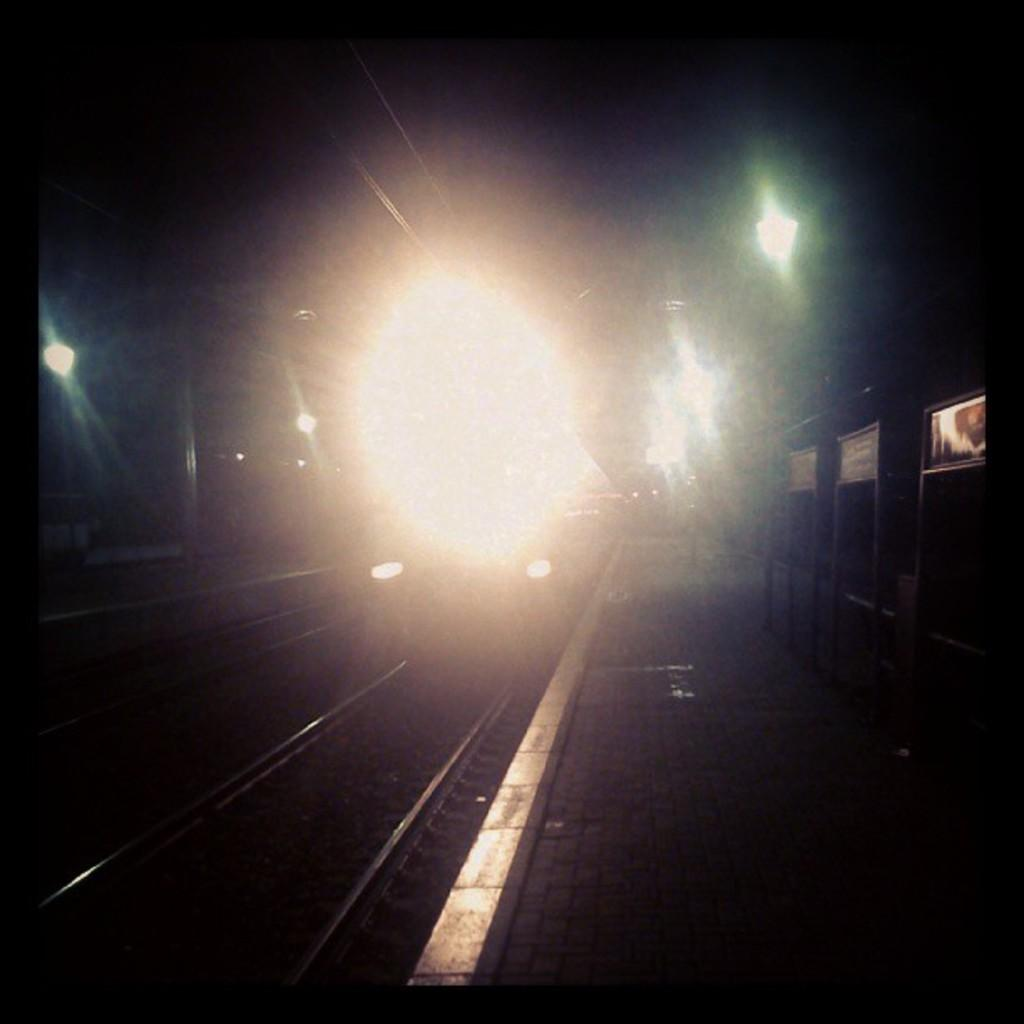What is the main subject of the image? The main subject of the image is a train. Where is the train located in the image? The train is on a track in the image. What can be seen on the right side of the image? There is a footpath on the right side of the image, and boards are present on the footpath. What is visible in the background of the image? In the background of the image, there are poles and lights. What type of cheese is being used to make the silk in the image? There is no cheese or silk present in the image; it features a train on a track with a footpath and background elements. 